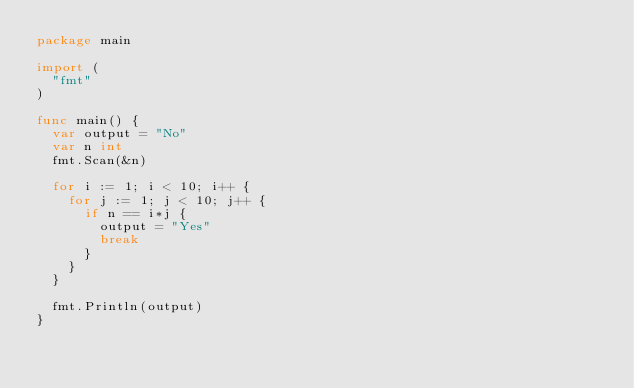Convert code to text. <code><loc_0><loc_0><loc_500><loc_500><_Go_>package main

import (
  "fmt"
)

func main() {
  var output = "No"
  var n int
  fmt.Scan(&n)

  for i := 1; i < 10; i++ {
    for j := 1; j < 10; j++ {
      if n == i*j {
        output = "Yes"
        break
      }
    }
  }
  
  fmt.Println(output)
}</code> 